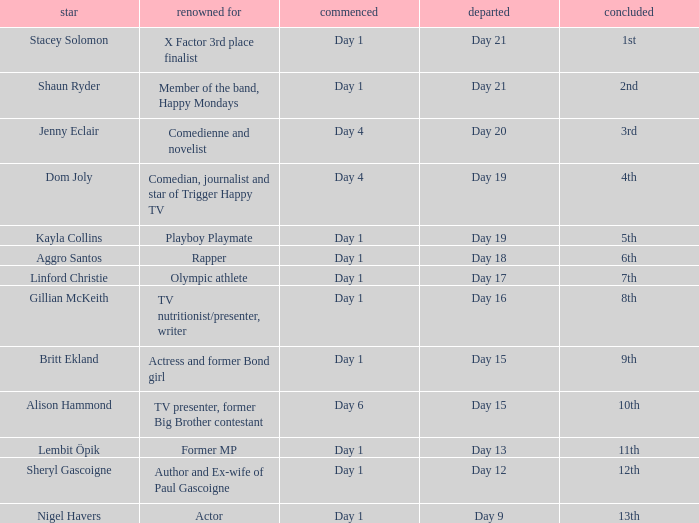Which celebrity was famous for being a rapper? Aggro Santos. 